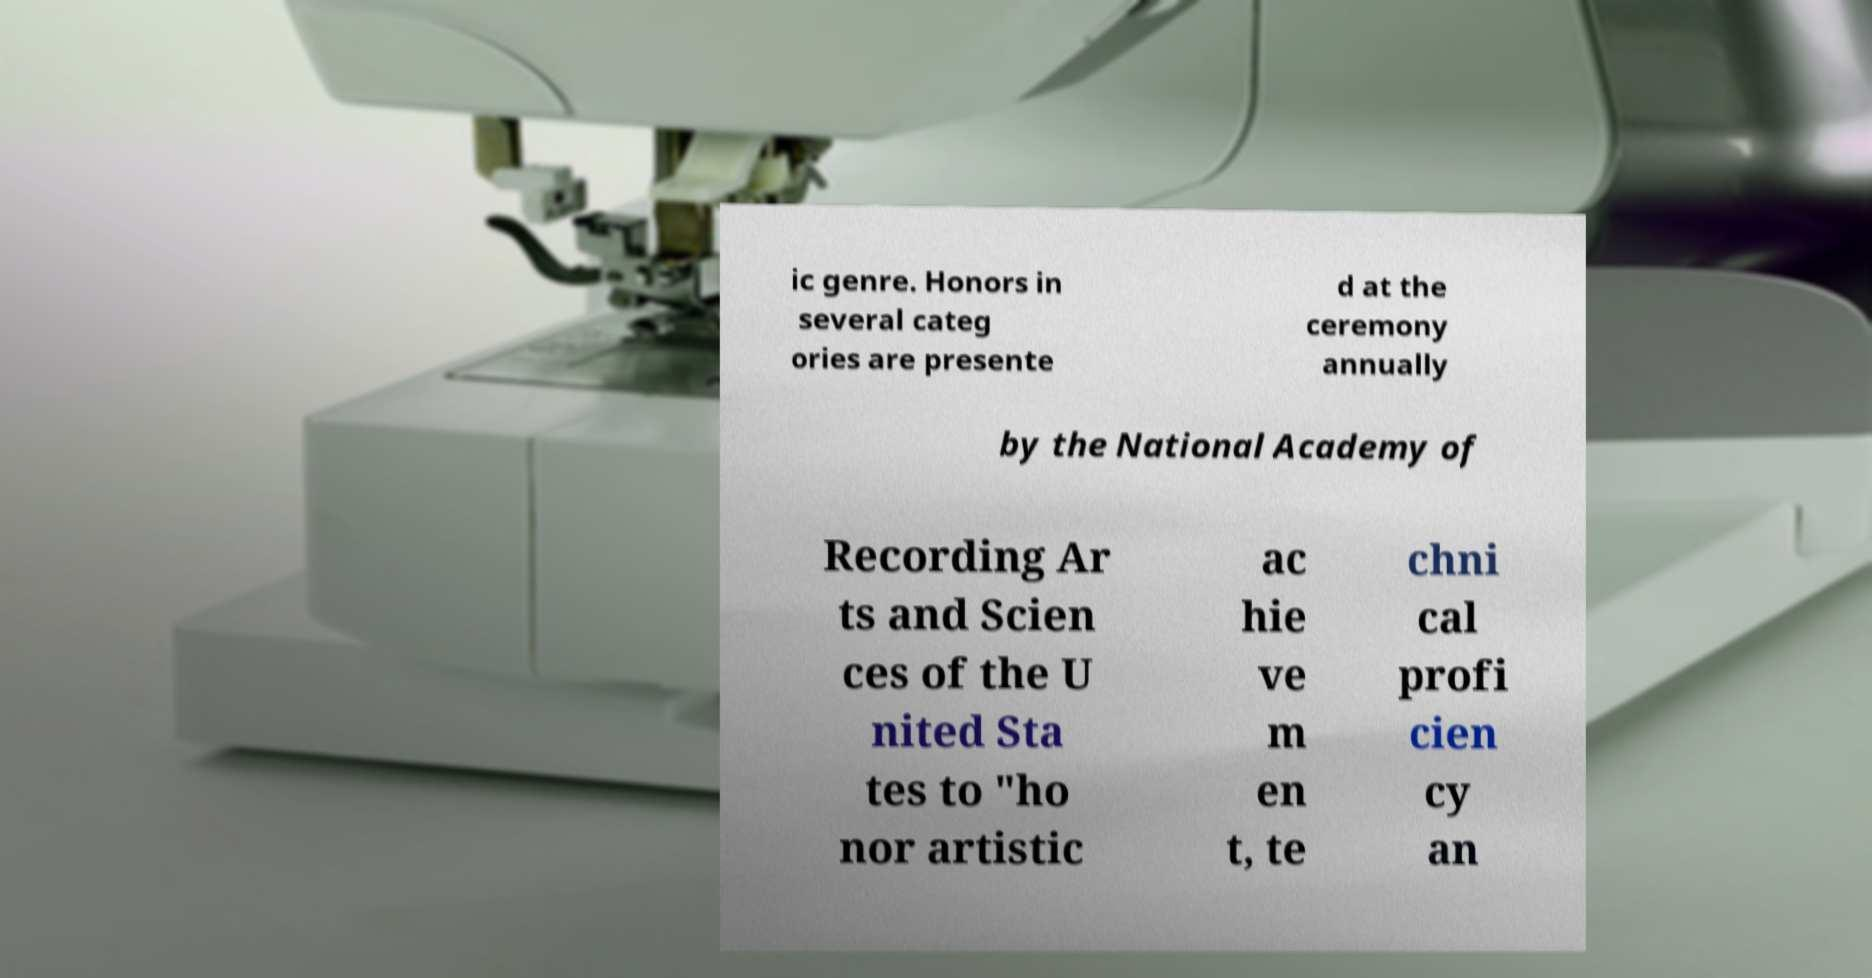Please identify and transcribe the text found in this image. ic genre. Honors in several categ ories are presente d at the ceremony annually by the National Academy of Recording Ar ts and Scien ces of the U nited Sta tes to "ho nor artistic ac hie ve m en t, te chni cal profi cien cy an 